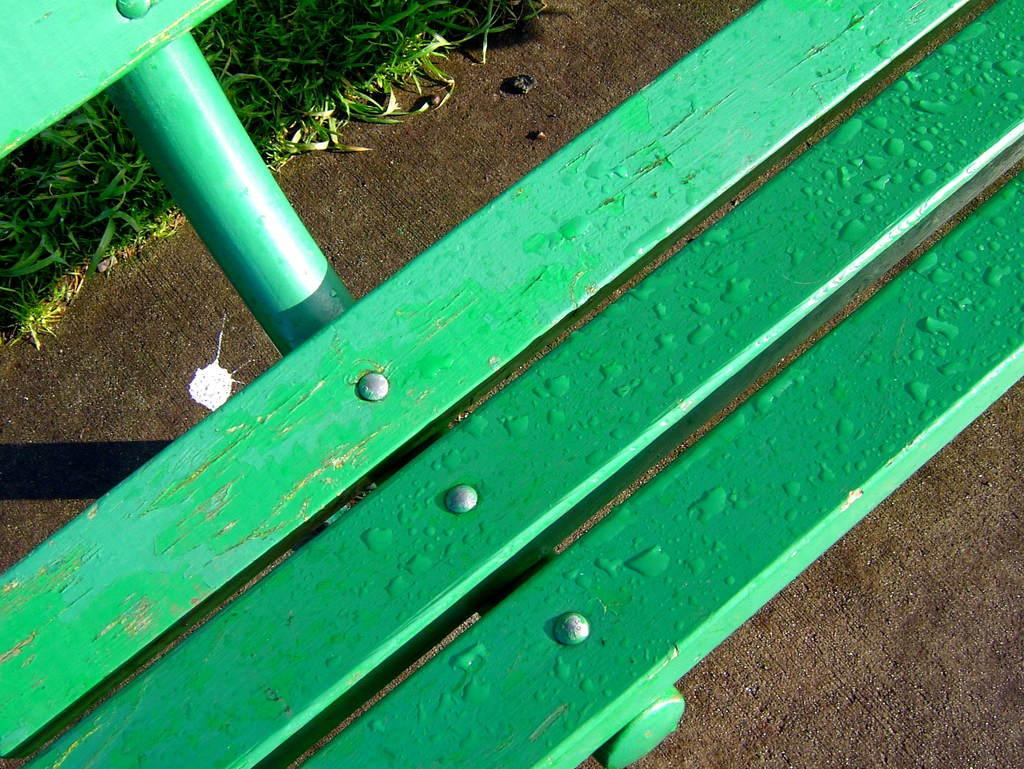What type of seating is present in the image? There is a bench chair in the image. What color is the bench chair? The bench chair is green in color. Can you describe the condition of the bench chair? There are water drops on the bench chair. What can be seen on the left side of the image? There is grass visible on the left side of the image. Can you see the toes of the person sitting on the bench chair in the image? There is no person sitting on the bench chair in the image, so we cannot see their toes. 